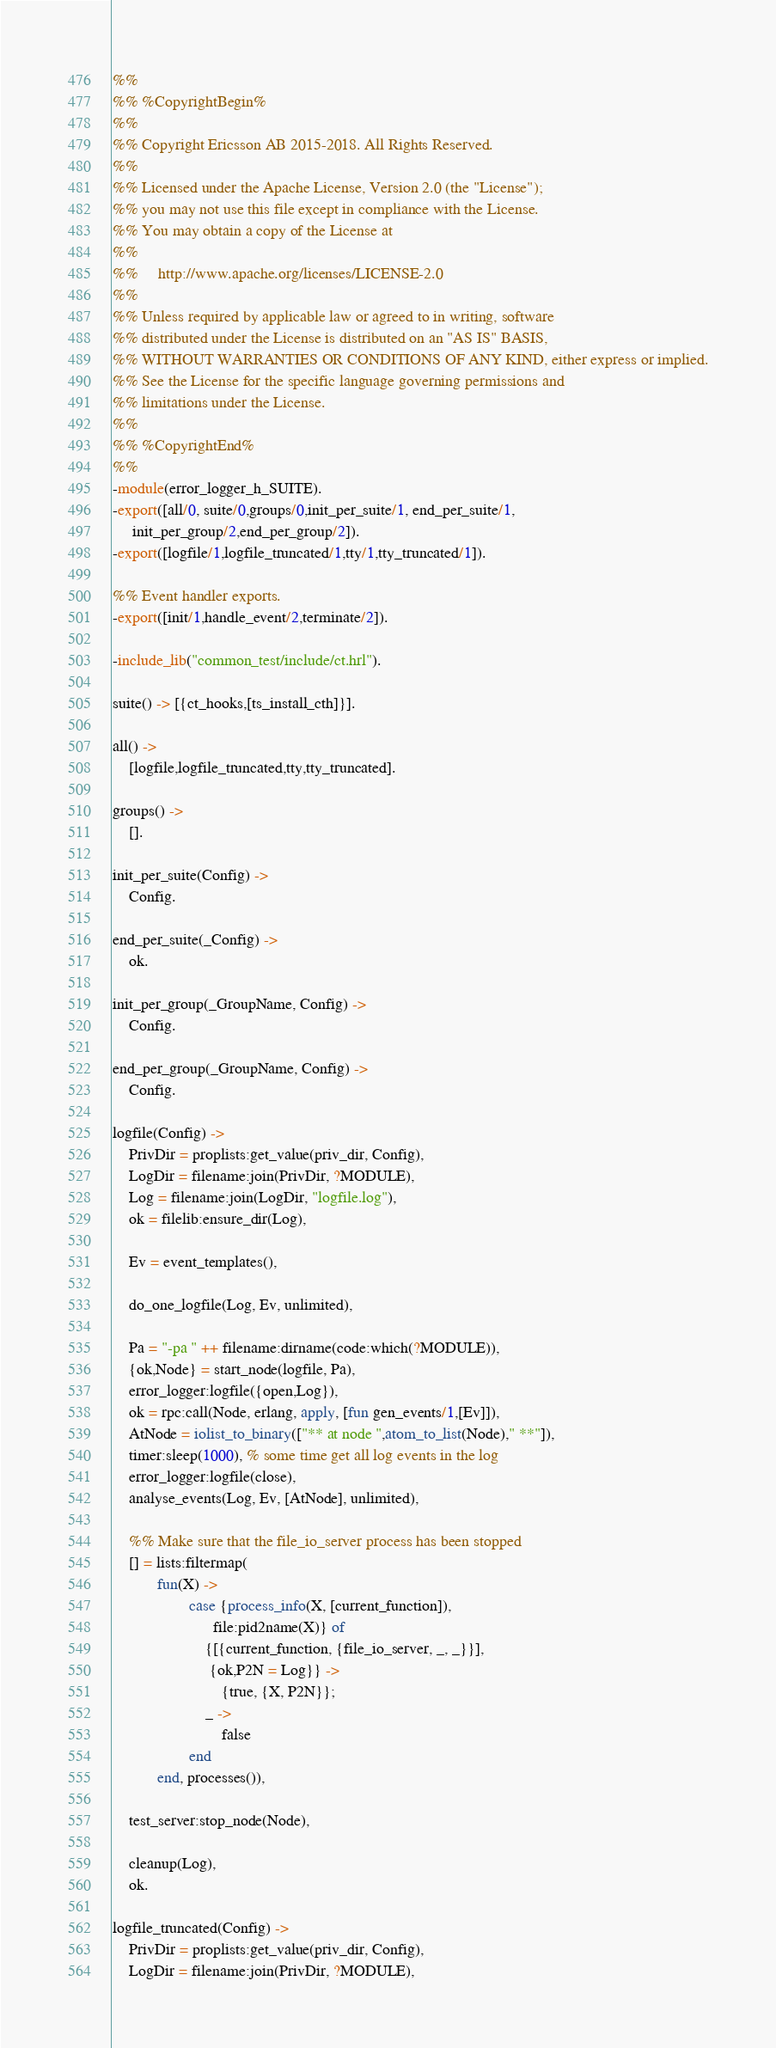Convert code to text. <code><loc_0><loc_0><loc_500><loc_500><_Erlang_>%%
%% %CopyrightBegin%
%%
%% Copyright Ericsson AB 2015-2018. All Rights Reserved.
%%
%% Licensed under the Apache License, Version 2.0 (the "License");
%% you may not use this file except in compliance with the License.
%% You may obtain a copy of the License at
%%
%%     http://www.apache.org/licenses/LICENSE-2.0
%%
%% Unless required by applicable law or agreed to in writing, software
%% distributed under the License is distributed on an "AS IS" BASIS,
%% WITHOUT WARRANTIES OR CONDITIONS OF ANY KIND, either express or implied.
%% See the License for the specific language governing permissions and
%% limitations under the License.
%%
%% %CopyrightEnd%
%%
-module(error_logger_h_SUITE).
-export([all/0, suite/0,groups/0,init_per_suite/1, end_per_suite/1,
	 init_per_group/2,end_per_group/2]).
-export([logfile/1,logfile_truncated/1,tty/1,tty_truncated/1]).

%% Event handler exports.
-export([init/1,handle_event/2,terminate/2]).

-include_lib("common_test/include/ct.hrl").

suite() -> [{ct_hooks,[ts_install_cth]}].

all() ->
    [logfile,logfile_truncated,tty,tty_truncated].

groups() ->
    [].

init_per_suite(Config) ->
    Config.

end_per_suite(_Config) ->
    ok.

init_per_group(_GroupName, Config) ->
    Config.

end_per_group(_GroupName, Config) ->
    Config.

logfile(Config) ->
    PrivDir = proplists:get_value(priv_dir, Config),
    LogDir = filename:join(PrivDir, ?MODULE),
    Log = filename:join(LogDir, "logfile.log"),
    ok = filelib:ensure_dir(Log),

    Ev = event_templates(),

    do_one_logfile(Log, Ev, unlimited),

    Pa = "-pa " ++ filename:dirname(code:which(?MODULE)),
    {ok,Node} = start_node(logfile, Pa),
    error_logger:logfile({open,Log}),
    ok = rpc:call(Node, erlang, apply, [fun gen_events/1,[Ev]]),
    AtNode = iolist_to_binary(["** at node ",atom_to_list(Node)," **"]),
    timer:sleep(1000), % some time get all log events in the log
    error_logger:logfile(close),
    analyse_events(Log, Ev, [AtNode], unlimited),

    %% Make sure that the file_io_server process has been stopped
    [] = lists:filtermap(
           fun(X) ->
                   case {process_info(X, [current_function]),
                         file:pid2name(X)} of
                       {[{current_function, {file_io_server, _, _}}],
                        {ok,P2N = Log}} ->
                           {true, {X, P2N}};
                       _ ->
                           false
                   end
           end, processes()),

    test_server:stop_node(Node),

    cleanup(Log),
    ok.

logfile_truncated(Config) ->
    PrivDir = proplists:get_value(priv_dir, Config),
    LogDir = filename:join(PrivDir, ?MODULE),</code> 